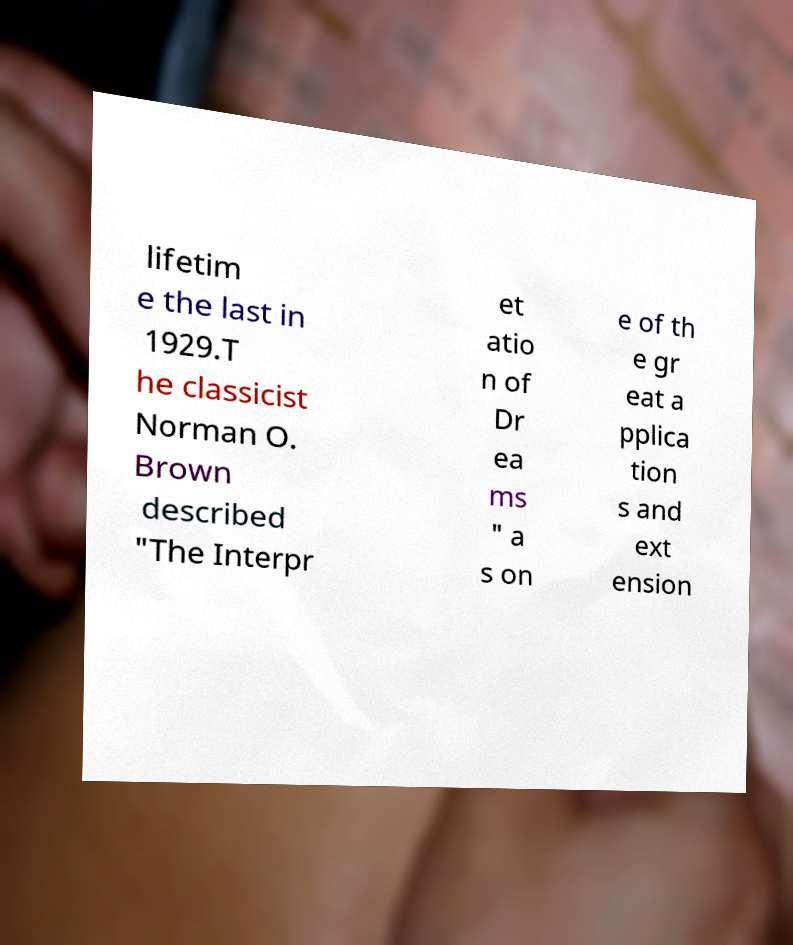Please read and relay the text visible in this image. What does it say? lifetim e the last in 1929.T he classicist Norman O. Brown described "The Interpr et atio n of Dr ea ms " a s on e of th e gr eat a pplica tion s and ext ension 